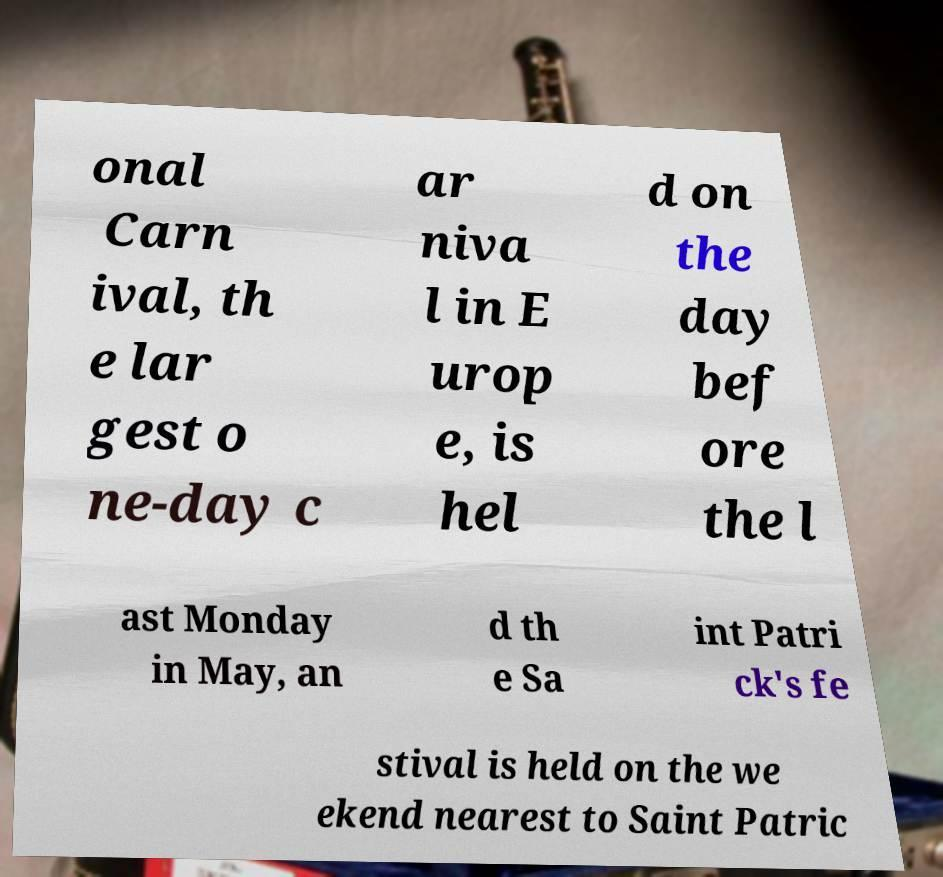What messages or text are displayed in this image? I need them in a readable, typed format. onal Carn ival, th e lar gest o ne-day c ar niva l in E urop e, is hel d on the day bef ore the l ast Monday in May, an d th e Sa int Patri ck's fe stival is held on the we ekend nearest to Saint Patric 